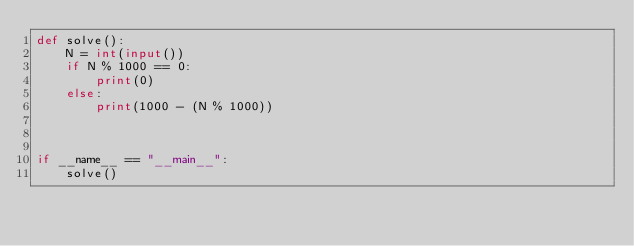Convert code to text. <code><loc_0><loc_0><loc_500><loc_500><_Python_>def solve():
    N = int(input())
    if N % 1000 == 0:
        print(0)
    else:
        print(1000 - (N % 1000))



if __name__ == "__main__":
    solve()</code> 